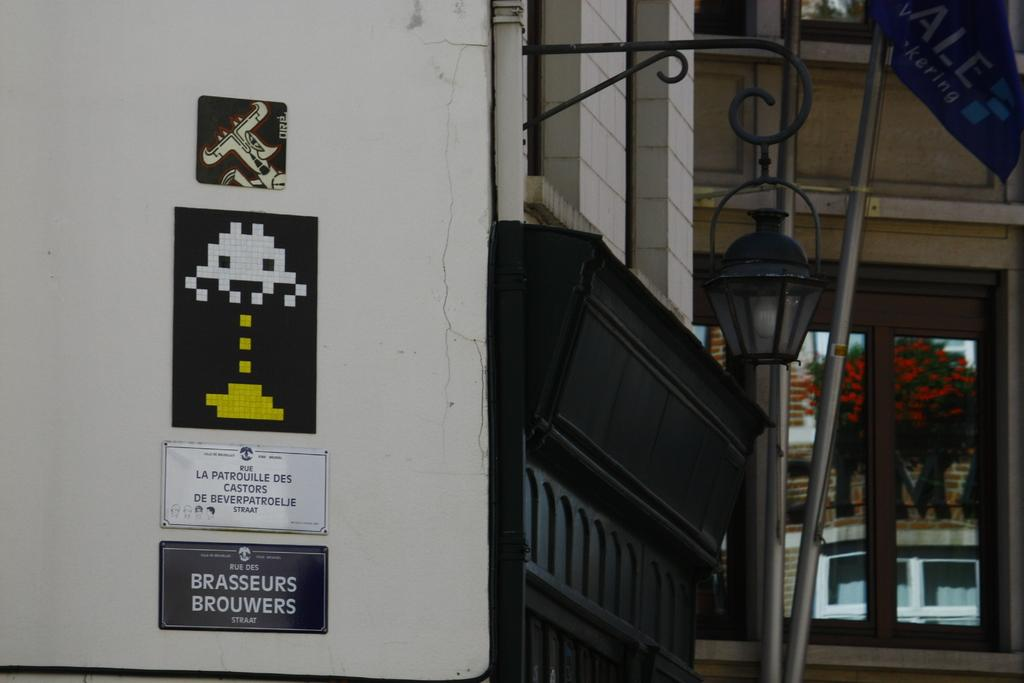What is attached to the wall on the left side of the image? There are boards on the left side of the image, attached to a wall. What can be seen on the right side of the image? There is a lamp on the right side of the image. What type of openings are present in the image? There are glass windows in the image. What type of punishment is being administered to the daughter in the image? There is no daughter or punishment present in the image. What is the daughter using to carry the yoke in the image? There is no daughter, yoke, or any related activity depicted in the image. 